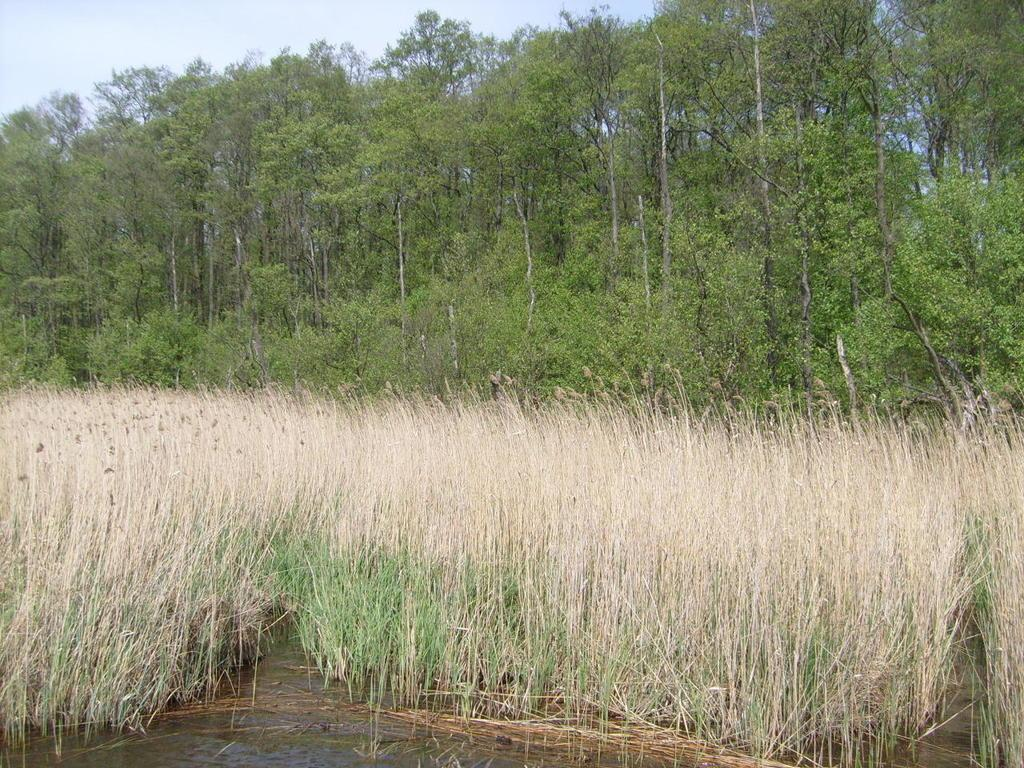What type of vegetation can be seen in the image? There are many trees and plants in the image. What is present at the bottom of the image? There is water at the bottom of the image. What can be seen at the top of the image? The sky is visible at the top of the image. Can you tell me which parent is sitting on the bench in the image? There are no parents or benches present in the image; it features trees, plants, water, and the sky. What type of hand can be seen holding a gavel in the image? There is no hand or gavel present in the image. 